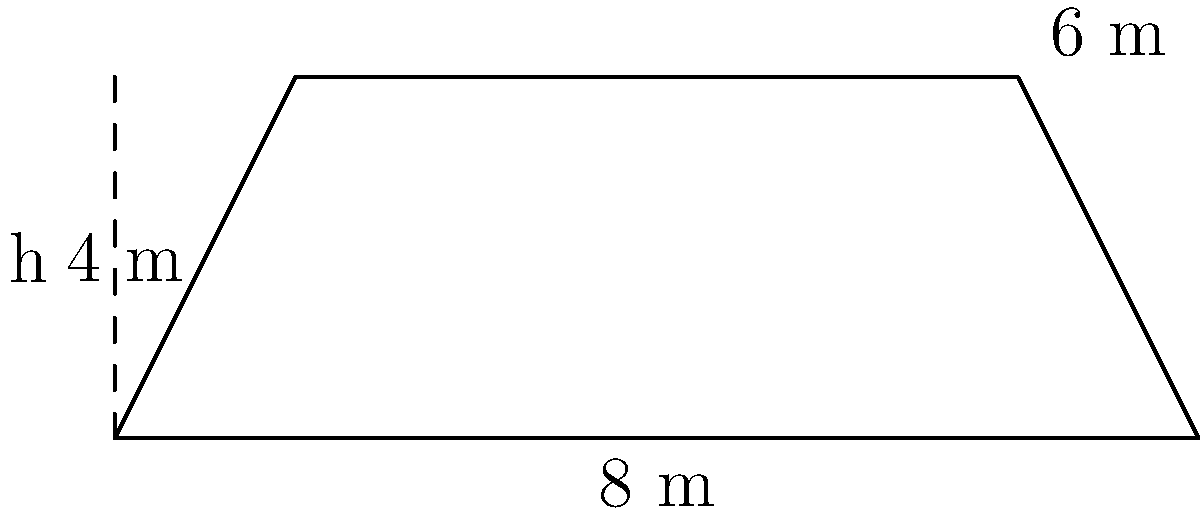You're designing a trapezoid-shaped banner for the next Shania Twain fan club meeting in Sydney. The banner's parallel sides measure 8 m and 6 m, with a height of 4 m. What is the area of the banner in square meters? To find the area of a trapezoid, we use the formula:

$$A = \frac{1}{2}(b_1 + b_2)h$$

Where:
$A$ = Area
$b_1$ and $b_2$ = Lengths of the parallel sides
$h$ = Height of the trapezoid

Given:
$b_1 = 8$ m (bottom base)
$b_2 = 6$ m (top base)
$h = 4$ m (height)

Let's substitute these values into the formula:

$$A = \frac{1}{2}(8 + 6) \times 4$$

$$A = \frac{1}{2}(14) \times 4$$

$$A = 7 \times 4$$

$$A = 28$$

Therefore, the area of the trapezoid-shaped banner is 28 square meters.
Answer: 28 m² 